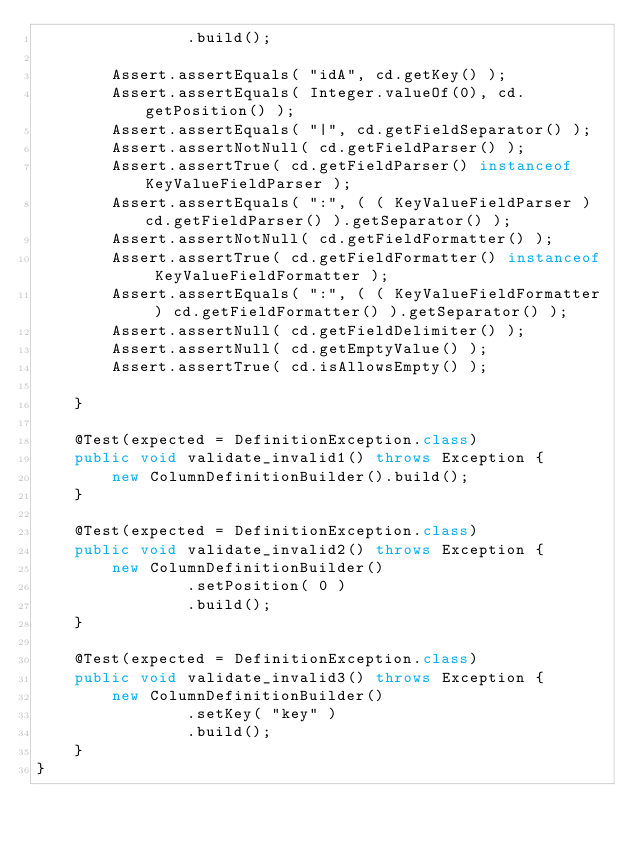Convert code to text. <code><loc_0><loc_0><loc_500><loc_500><_Java_>                .build();

        Assert.assertEquals( "idA", cd.getKey() );
        Assert.assertEquals( Integer.valueOf(0), cd.getPosition() );
        Assert.assertEquals( "|", cd.getFieldSeparator() );
        Assert.assertNotNull( cd.getFieldParser() );
        Assert.assertTrue( cd.getFieldParser() instanceof KeyValueFieldParser );
        Assert.assertEquals( ":", ( ( KeyValueFieldParser ) cd.getFieldParser() ).getSeparator() );
        Assert.assertNotNull( cd.getFieldFormatter() );
        Assert.assertTrue( cd.getFieldFormatter() instanceof KeyValueFieldFormatter );
        Assert.assertEquals( ":", ( ( KeyValueFieldFormatter ) cd.getFieldFormatter() ).getSeparator() );
        Assert.assertNull( cd.getFieldDelimiter() );
        Assert.assertNull( cd.getEmptyValue() );
        Assert.assertTrue( cd.isAllowsEmpty() );

    }

    @Test(expected = DefinitionException.class)
    public void validate_invalid1() throws Exception {
        new ColumnDefinitionBuilder().build();
    }

    @Test(expected = DefinitionException.class)
    public void validate_invalid2() throws Exception {
        new ColumnDefinitionBuilder()
                .setPosition( 0 )
                .build();
    }

    @Test(expected = DefinitionException.class)
    public void validate_invalid3() throws Exception {
        new ColumnDefinitionBuilder()
                .setKey( "key" )
                .build();
    }
}
</code> 